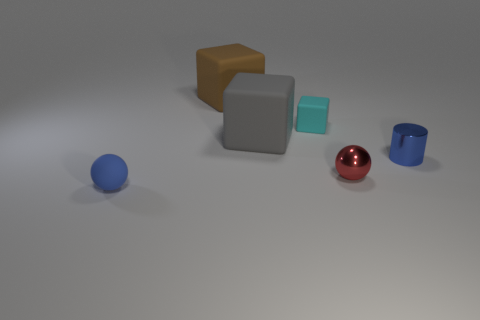Is there a sense of depth in this image, and if so, how is it achieved? There is a modest sense of depth in the image, primarily achieved through perspective and the arrangement of objects. The objects are spaced out with the blue sphere at the front and the large brown cube at the back, creating a sense of distance. Furthermore, the varying sizes of the objects contribute to the perception of depth, as do the soft shadows that provide cues about their spatial relationships. 